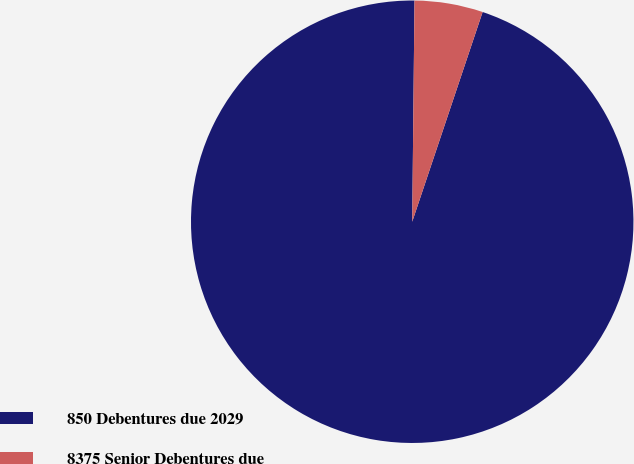<chart> <loc_0><loc_0><loc_500><loc_500><pie_chart><fcel>850 Debentures due 2029<fcel>8375 Senior Debentures due<nl><fcel>95.01%<fcel>4.99%<nl></chart> 